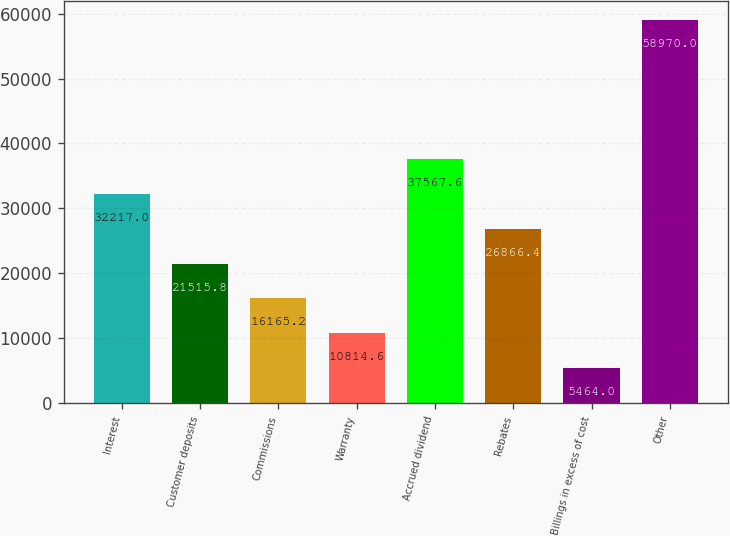Convert chart to OTSL. <chart><loc_0><loc_0><loc_500><loc_500><bar_chart><fcel>Interest<fcel>Customer deposits<fcel>Commissions<fcel>Warranty<fcel>Accrued dividend<fcel>Rebates<fcel>Billings in excess of cost<fcel>Other<nl><fcel>32217<fcel>21515.8<fcel>16165.2<fcel>10814.6<fcel>37567.6<fcel>26866.4<fcel>5464<fcel>58970<nl></chart> 